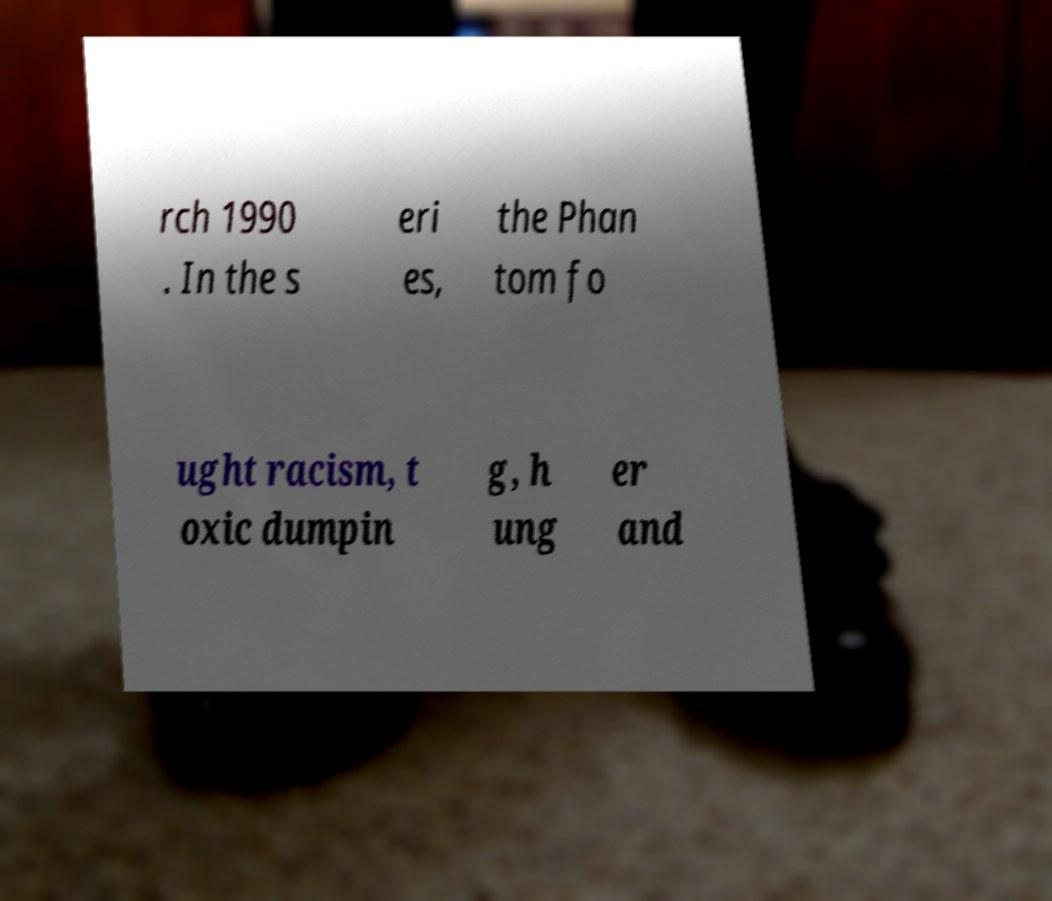There's text embedded in this image that I need extracted. Can you transcribe it verbatim? rch 1990 . In the s eri es, the Phan tom fo ught racism, t oxic dumpin g, h ung er and 